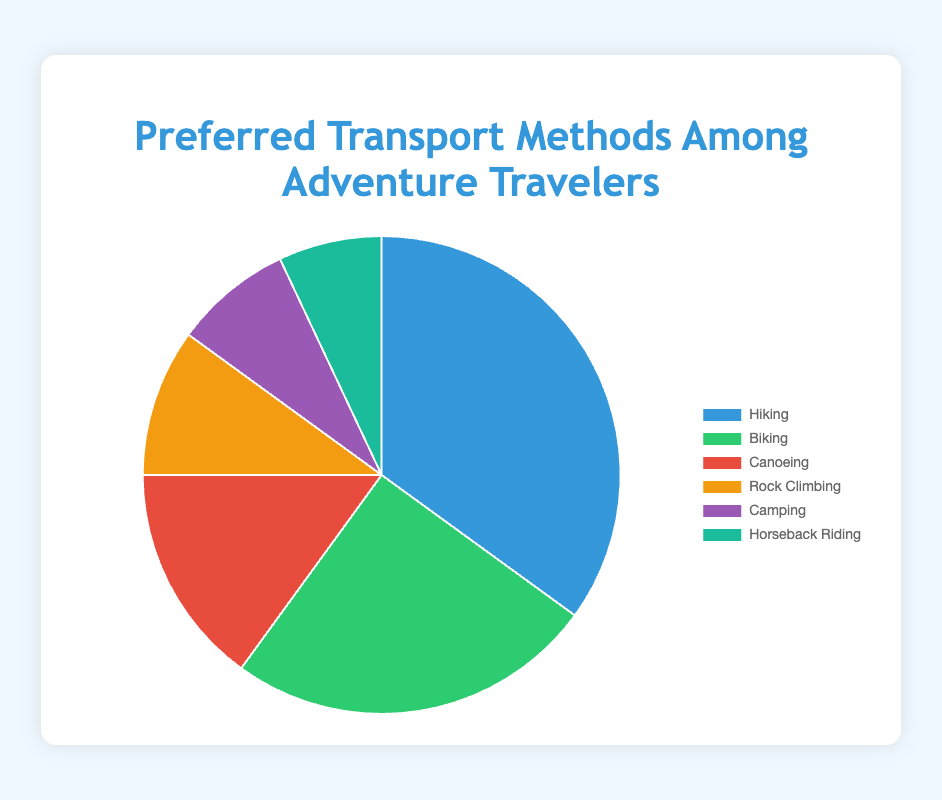Which transport method is preferred by the largest percentage of adventure travelers? By examining the segments of the pie chart, the largest portion corresponds to Hiking.
Answer: Hiking Which transport method has the smallest percentage among adventure travelers? The smallest segment in the pie chart belongs to Horseback Riding.
Answer: Horseback Riding How much more popular is Hiking compared to Canoeing among adventure travelers? Hiking accounts for 35%, and Canoeing accounts for 15%. The difference is 35% - 15% = 20%.
Answer: 20% What is the combined percentage of people who prefer Biking and Camping? Biking accounts for 25% and Camping accounts for 8%. The combined percentage is 25% + 8% = 33%.
Answer: 33% What is the least popular activity among Rock Climbing, Camping, and Horseback Riding? Among the three activities, Horseback Riding, with 7%, is the least popular compared to Rock Climbing (10%) and Camping (8%).
Answer: Horseback Riding Which color represents Canoeing in the pie chart? The pie chart segment for Canoeing is colored red.
Answer: Red How does the popularity of Camping compare to Rock Climbing? Camping accounts for 8%, and Rock Climbing accounts for 10%. Therefore, Rock Climbing is more popular.
Answer: Rock Climbing What percentage of adventure travelers prefer water-based activities (Canoeing)? Canoeing is a water-based activity, and it accounts for 15% in the pie chart.
Answer: 15% What is the total percentage of adventure travelers who prefer non-hiking activities? Non-hiking activities include Biking (25%), Canoeing (15%), Rock Climbing (10%), Camping (8%), and Horseback Riding (7%). Their combined percentage is 25% + 15% + 10% + 8% + 7% = 65%.
Answer: 65% What are the second and third most popular transport methods among adventure travelers? The second most popular method is Biking (25%), and the third most popular method is Canoeing (15%).
Answer: Biking, Canoeing 